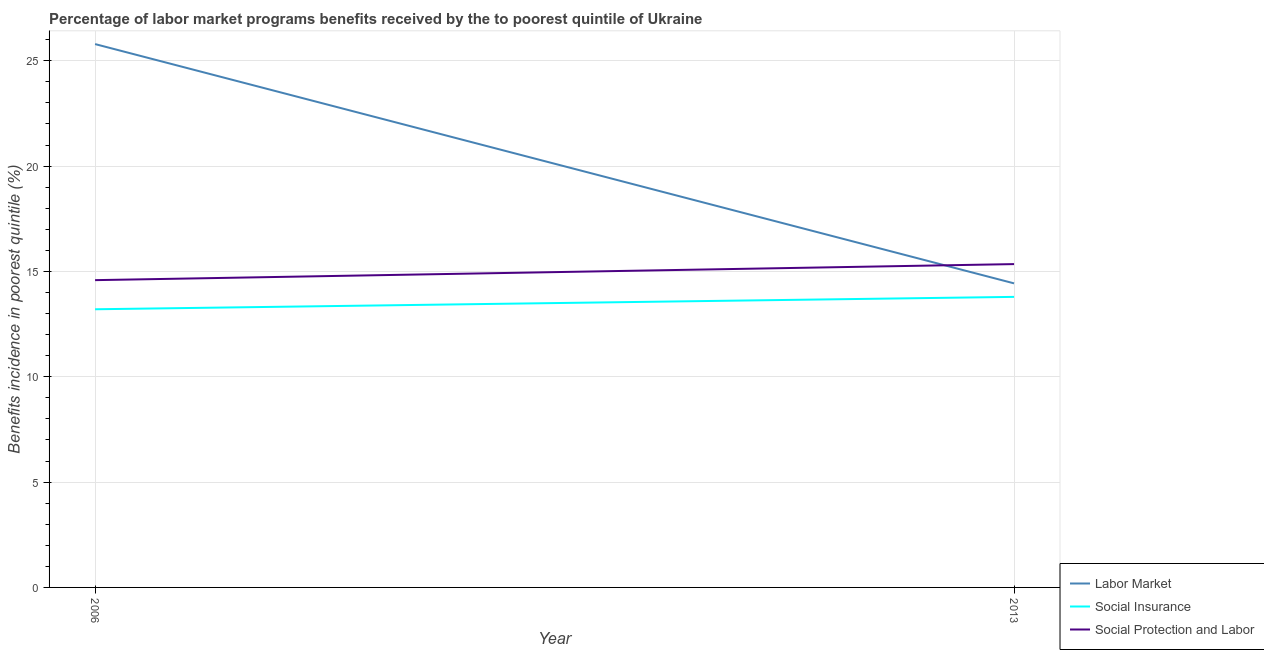How many different coloured lines are there?
Make the answer very short. 3. Does the line corresponding to percentage of benefits received due to social insurance programs intersect with the line corresponding to percentage of benefits received due to social protection programs?
Make the answer very short. No. What is the percentage of benefits received due to social protection programs in 2006?
Keep it short and to the point. 14.59. Across all years, what is the maximum percentage of benefits received due to labor market programs?
Your response must be concise. 25.79. Across all years, what is the minimum percentage of benefits received due to labor market programs?
Provide a short and direct response. 14.43. In which year was the percentage of benefits received due to social insurance programs minimum?
Offer a terse response. 2006. What is the total percentage of benefits received due to labor market programs in the graph?
Provide a short and direct response. 40.22. What is the difference between the percentage of benefits received due to labor market programs in 2006 and that in 2013?
Keep it short and to the point. 11.36. What is the difference between the percentage of benefits received due to labor market programs in 2013 and the percentage of benefits received due to social protection programs in 2006?
Keep it short and to the point. -0.15. What is the average percentage of benefits received due to social insurance programs per year?
Give a very brief answer. 13.5. In the year 2006, what is the difference between the percentage of benefits received due to labor market programs and percentage of benefits received due to social insurance programs?
Provide a short and direct response. 12.59. In how many years, is the percentage of benefits received due to social protection programs greater than 17 %?
Your answer should be very brief. 0. What is the ratio of the percentage of benefits received due to social insurance programs in 2006 to that in 2013?
Ensure brevity in your answer.  0.96. Is it the case that in every year, the sum of the percentage of benefits received due to labor market programs and percentage of benefits received due to social insurance programs is greater than the percentage of benefits received due to social protection programs?
Provide a short and direct response. Yes. Does the percentage of benefits received due to social protection programs monotonically increase over the years?
Provide a short and direct response. Yes. How many lines are there?
Provide a short and direct response. 3. How many years are there in the graph?
Your response must be concise. 2. Does the graph contain any zero values?
Your answer should be very brief. No. Where does the legend appear in the graph?
Provide a short and direct response. Bottom right. What is the title of the graph?
Your response must be concise. Percentage of labor market programs benefits received by the to poorest quintile of Ukraine. Does "Tertiary" appear as one of the legend labels in the graph?
Make the answer very short. No. What is the label or title of the X-axis?
Give a very brief answer. Year. What is the label or title of the Y-axis?
Keep it short and to the point. Benefits incidence in poorest quintile (%). What is the Benefits incidence in poorest quintile (%) of Labor Market in 2006?
Offer a very short reply. 25.79. What is the Benefits incidence in poorest quintile (%) in Social Insurance in 2006?
Your answer should be very brief. 13.2. What is the Benefits incidence in poorest quintile (%) of Social Protection and Labor in 2006?
Offer a terse response. 14.59. What is the Benefits incidence in poorest quintile (%) of Labor Market in 2013?
Ensure brevity in your answer.  14.43. What is the Benefits incidence in poorest quintile (%) in Social Insurance in 2013?
Your response must be concise. 13.79. What is the Benefits incidence in poorest quintile (%) of Social Protection and Labor in 2013?
Keep it short and to the point. 15.35. Across all years, what is the maximum Benefits incidence in poorest quintile (%) in Labor Market?
Your answer should be very brief. 25.79. Across all years, what is the maximum Benefits incidence in poorest quintile (%) of Social Insurance?
Offer a very short reply. 13.79. Across all years, what is the maximum Benefits incidence in poorest quintile (%) in Social Protection and Labor?
Provide a short and direct response. 15.35. Across all years, what is the minimum Benefits incidence in poorest quintile (%) in Labor Market?
Offer a terse response. 14.43. Across all years, what is the minimum Benefits incidence in poorest quintile (%) in Social Insurance?
Provide a succinct answer. 13.2. Across all years, what is the minimum Benefits incidence in poorest quintile (%) of Social Protection and Labor?
Provide a succinct answer. 14.59. What is the total Benefits incidence in poorest quintile (%) of Labor Market in the graph?
Provide a succinct answer. 40.22. What is the total Benefits incidence in poorest quintile (%) of Social Insurance in the graph?
Provide a short and direct response. 26.99. What is the total Benefits incidence in poorest quintile (%) in Social Protection and Labor in the graph?
Offer a terse response. 29.93. What is the difference between the Benefits incidence in poorest quintile (%) of Labor Market in 2006 and that in 2013?
Ensure brevity in your answer.  11.36. What is the difference between the Benefits incidence in poorest quintile (%) in Social Insurance in 2006 and that in 2013?
Make the answer very short. -0.59. What is the difference between the Benefits incidence in poorest quintile (%) in Social Protection and Labor in 2006 and that in 2013?
Ensure brevity in your answer.  -0.76. What is the difference between the Benefits incidence in poorest quintile (%) of Labor Market in 2006 and the Benefits incidence in poorest quintile (%) of Social Insurance in 2013?
Keep it short and to the point. 12. What is the difference between the Benefits incidence in poorest quintile (%) of Labor Market in 2006 and the Benefits incidence in poorest quintile (%) of Social Protection and Labor in 2013?
Give a very brief answer. 10.44. What is the difference between the Benefits incidence in poorest quintile (%) of Social Insurance in 2006 and the Benefits incidence in poorest quintile (%) of Social Protection and Labor in 2013?
Provide a short and direct response. -2.14. What is the average Benefits incidence in poorest quintile (%) in Labor Market per year?
Keep it short and to the point. 20.11. What is the average Benefits incidence in poorest quintile (%) of Social Insurance per year?
Provide a succinct answer. 13.5. What is the average Benefits incidence in poorest quintile (%) in Social Protection and Labor per year?
Provide a short and direct response. 14.97. In the year 2006, what is the difference between the Benefits incidence in poorest quintile (%) of Labor Market and Benefits incidence in poorest quintile (%) of Social Insurance?
Make the answer very short. 12.59. In the year 2006, what is the difference between the Benefits incidence in poorest quintile (%) of Labor Market and Benefits incidence in poorest quintile (%) of Social Protection and Labor?
Offer a very short reply. 11.21. In the year 2006, what is the difference between the Benefits incidence in poorest quintile (%) of Social Insurance and Benefits incidence in poorest quintile (%) of Social Protection and Labor?
Ensure brevity in your answer.  -1.38. In the year 2013, what is the difference between the Benefits incidence in poorest quintile (%) in Labor Market and Benefits incidence in poorest quintile (%) in Social Insurance?
Provide a short and direct response. 0.64. In the year 2013, what is the difference between the Benefits incidence in poorest quintile (%) of Labor Market and Benefits incidence in poorest quintile (%) of Social Protection and Labor?
Give a very brief answer. -0.91. In the year 2013, what is the difference between the Benefits incidence in poorest quintile (%) in Social Insurance and Benefits incidence in poorest quintile (%) in Social Protection and Labor?
Your answer should be compact. -1.56. What is the ratio of the Benefits incidence in poorest quintile (%) of Labor Market in 2006 to that in 2013?
Offer a very short reply. 1.79. What is the ratio of the Benefits incidence in poorest quintile (%) in Social Insurance in 2006 to that in 2013?
Give a very brief answer. 0.96. What is the ratio of the Benefits incidence in poorest quintile (%) in Social Protection and Labor in 2006 to that in 2013?
Your response must be concise. 0.95. What is the difference between the highest and the second highest Benefits incidence in poorest quintile (%) in Labor Market?
Offer a very short reply. 11.36. What is the difference between the highest and the second highest Benefits incidence in poorest quintile (%) of Social Insurance?
Provide a short and direct response. 0.59. What is the difference between the highest and the second highest Benefits incidence in poorest quintile (%) in Social Protection and Labor?
Provide a short and direct response. 0.76. What is the difference between the highest and the lowest Benefits incidence in poorest quintile (%) in Labor Market?
Keep it short and to the point. 11.36. What is the difference between the highest and the lowest Benefits incidence in poorest quintile (%) in Social Insurance?
Give a very brief answer. 0.59. What is the difference between the highest and the lowest Benefits incidence in poorest quintile (%) of Social Protection and Labor?
Your answer should be very brief. 0.76. 